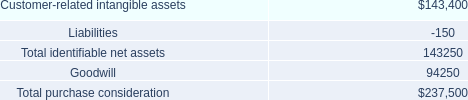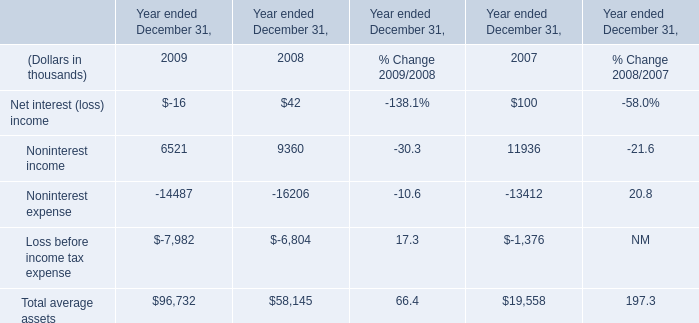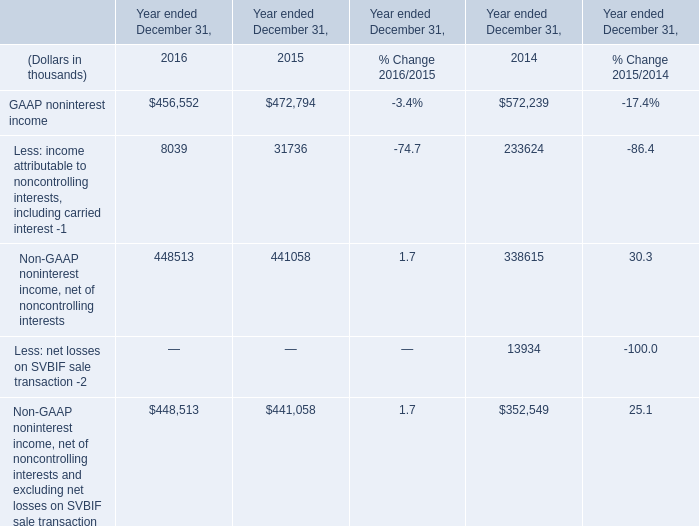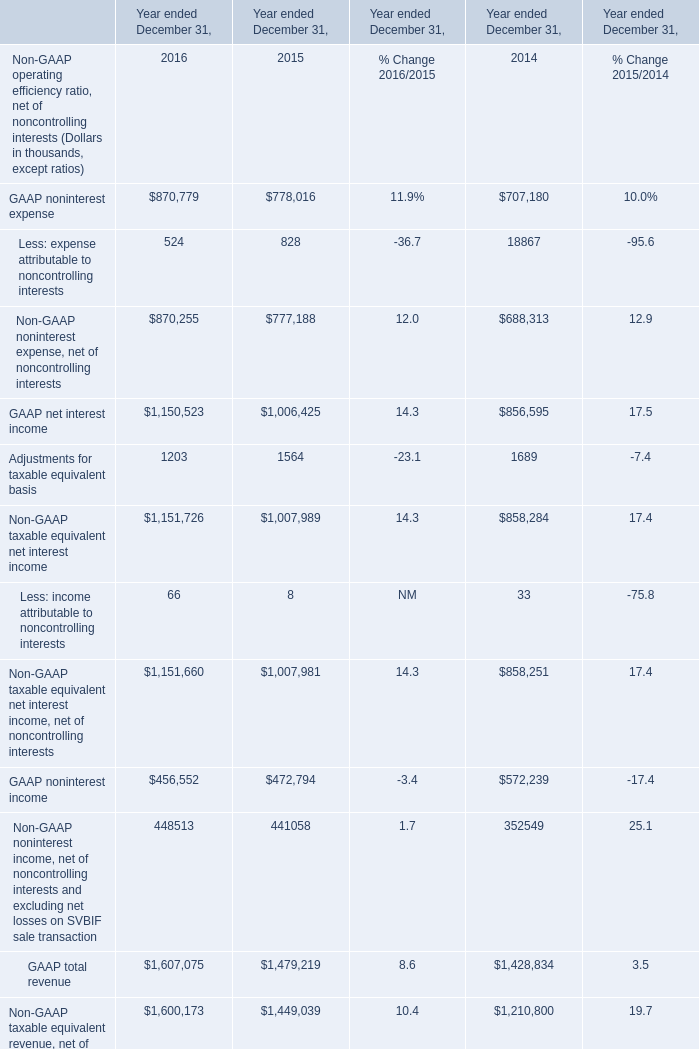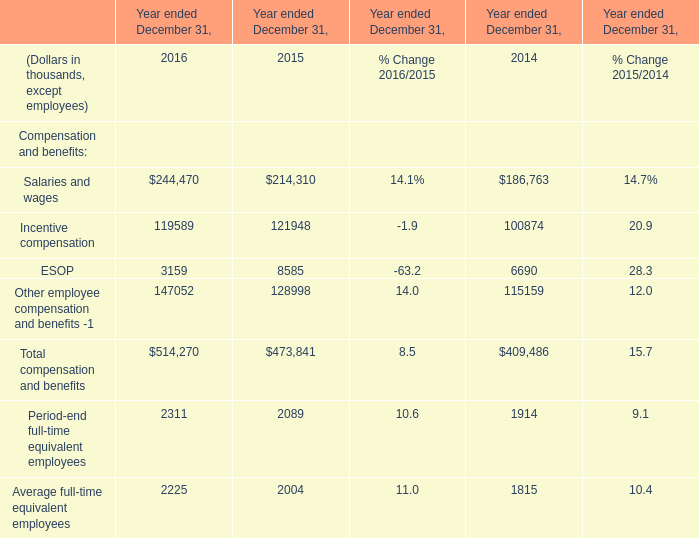What is the sum of GAAP noninterest income in 2016 and Noninterest income in 2009? (in thousand) 
Computations: (456552 + 6521)
Answer: 463073.0. 